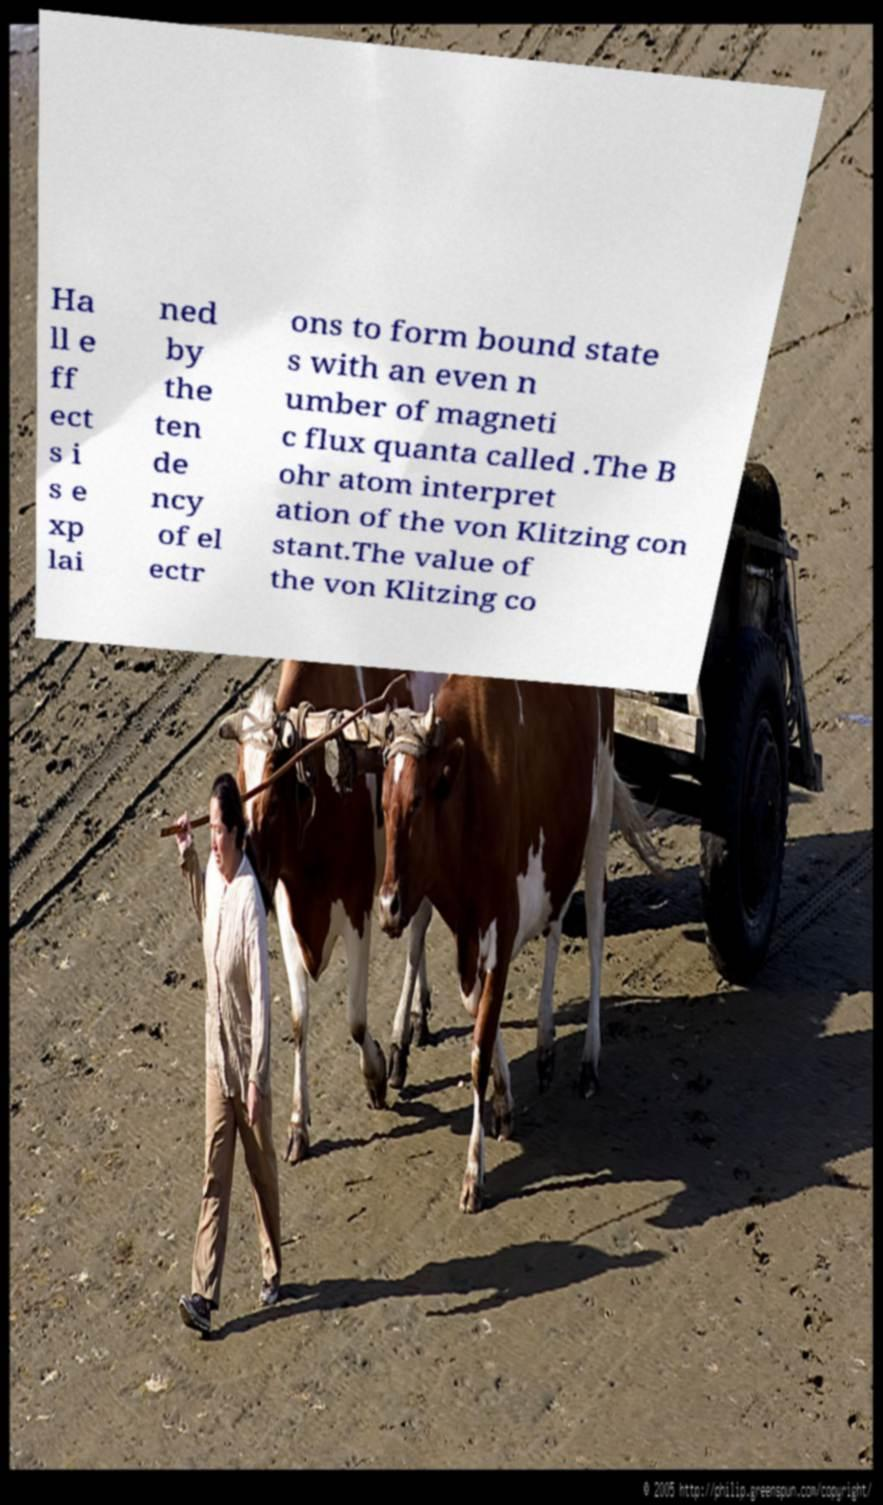Can you accurately transcribe the text from the provided image for me? Ha ll e ff ect s i s e xp lai ned by the ten de ncy of el ectr ons to form bound state s with an even n umber of magneti c flux quanta called .The B ohr atom interpret ation of the von Klitzing con stant.The value of the von Klitzing co 